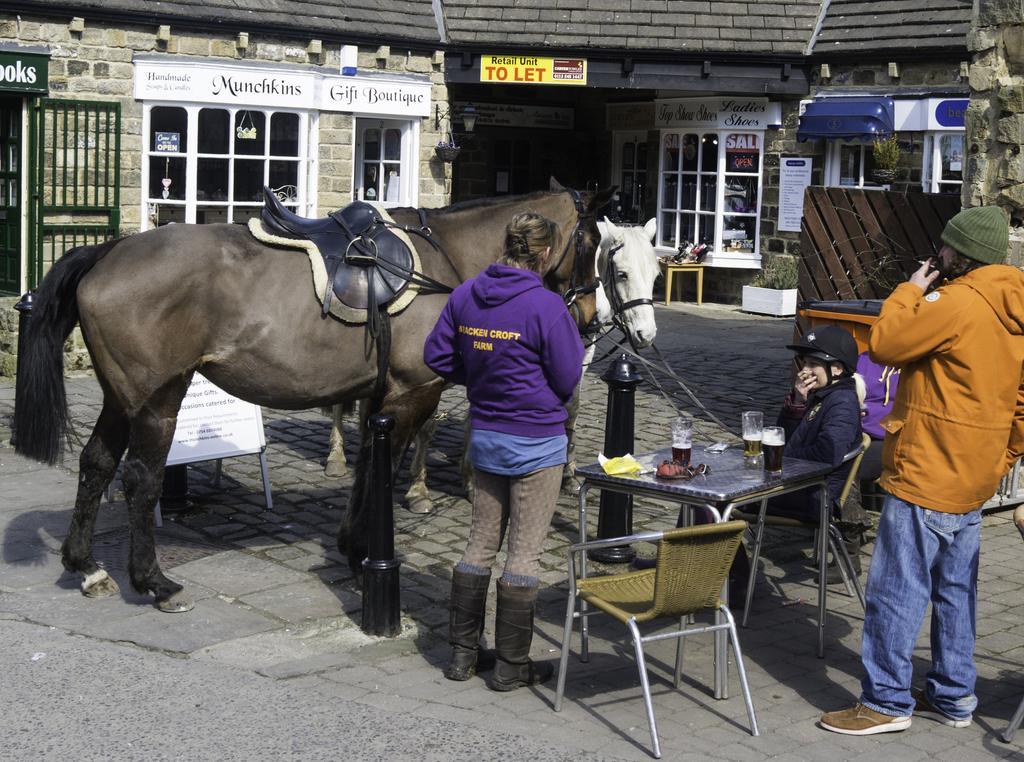In one or two sentences, can you explain what this image depicts? The photo is taken outside a building. There is a brown horse beside it there is a white horse. There are few people standing. Here there are table and chair. On the table there are glasses. Few people are sitting beside the table. In the background there is a building. 